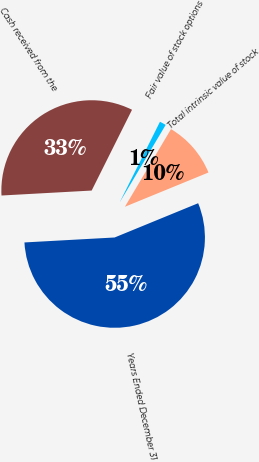Convert chart to OTSL. <chart><loc_0><loc_0><loc_500><loc_500><pie_chart><fcel>Years Ended December 31<fcel>Total intrinsic value of stock<fcel>Fair value of stock options<fcel>Cash received from the<nl><fcel>55.32%<fcel>10.28%<fcel>1.15%<fcel>33.25%<nl></chart> 